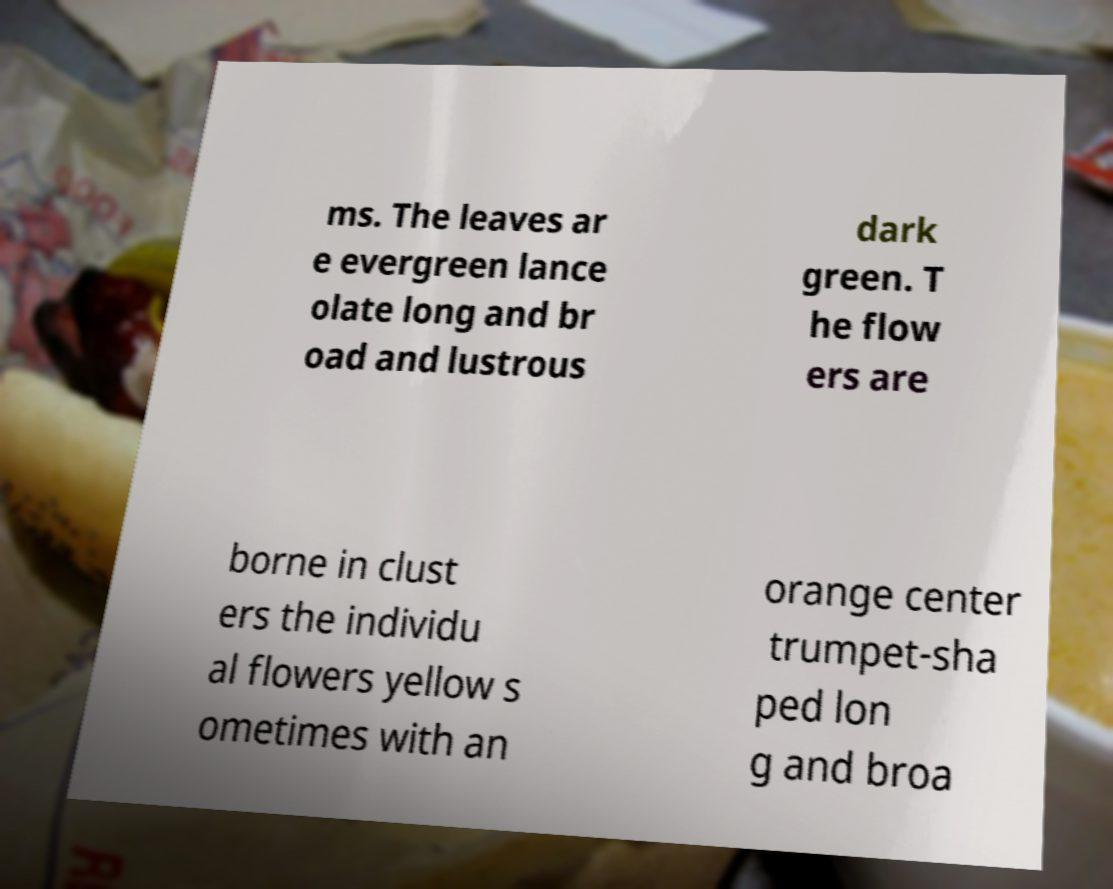Please identify and transcribe the text found in this image. ms. The leaves ar e evergreen lance olate long and br oad and lustrous dark green. T he flow ers are borne in clust ers the individu al flowers yellow s ometimes with an orange center trumpet-sha ped lon g and broa 